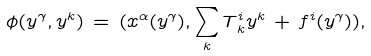<formula> <loc_0><loc_0><loc_500><loc_500>\phi ( y ^ { \gamma } , y ^ { k } ) \, = \, ( x ^ { \alpha } ( y ^ { \gamma } ) , \sum _ { k } T ^ { i } _ { \, k } y ^ { k } \, + \, f ^ { i } ( y ^ { \gamma } ) ) ,</formula> 